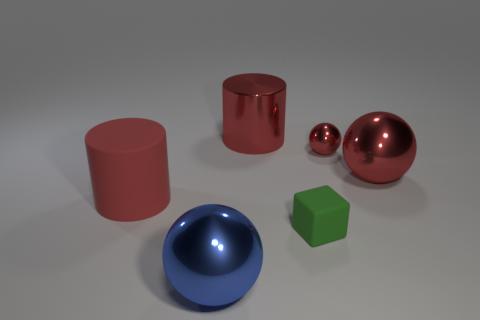How many red cylinders must be subtracted to get 1 red cylinders? 1 Add 4 big red metallic cylinders. How many objects exist? 10 Subtract all cylinders. How many objects are left? 4 Add 4 big red rubber objects. How many big red rubber objects are left? 5 Add 3 green matte things. How many green matte things exist? 4 Subtract 1 blue spheres. How many objects are left? 5 Subtract all big metallic things. Subtract all small metallic objects. How many objects are left? 2 